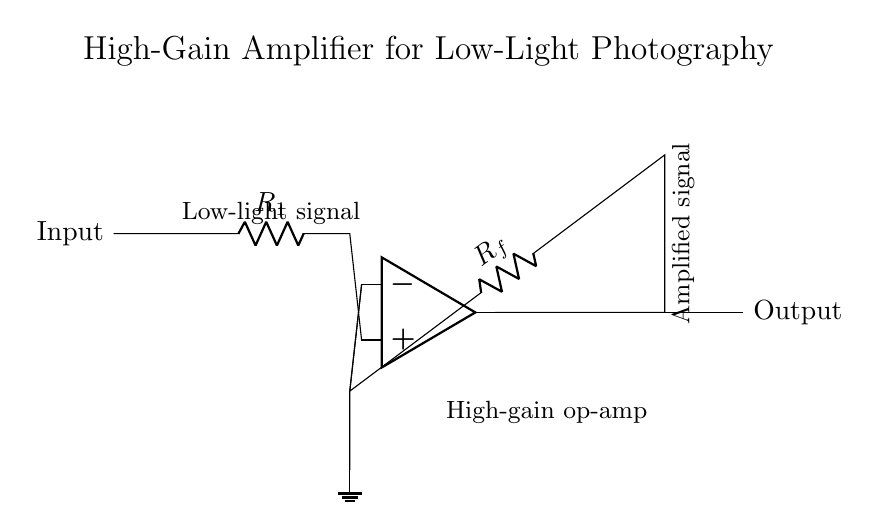What type of circuit is this? This circuit is an operational amplifier configuration, specifically designed for amplifying signals. It includes input and output connections, as well as feedback and resistors crucial for its operation.
Answer: Operational amplifier What is R1 used for in this circuit? R1 is the input resistor that controls the amount of current flowing into the operational amplifier. It plays a role in determining the overall gain of the circuit when used with the feedback resistor Rf.
Answer: Input resistor What is the purpose of the feedback resistor Rf? Rf is used in the feedback loop of the operational amplifier to set the gain of the amplifier. The value of Rf, along with R1, dictates how much the input signal is amplified.
Answer: Set gain What type of signal is indicated at the input? The input signal is described as a low-light signal, which suggests it may have low voltage levels that require amplification for better processing and analysis.
Answer: Low-light signal How does this circuit enhance low-light signals? The circuit enhances low-light signals by using a high-gain operational amplifier configuration, which significantly increases the voltage levels of weak input signals, making them more detectable and usable.
Answer: By amplification What happens to the signal at the output? The output signal is an amplified version of the low-light input signal, providing a stronger signal for further processing or display. This amplification is essential for capturing images in low-light conditions.
Answer: Amplified signal 